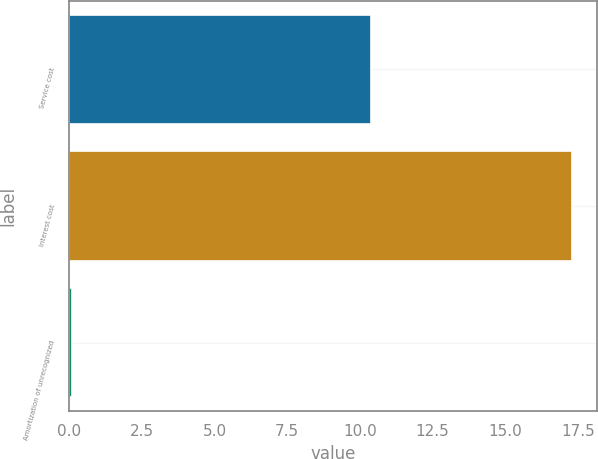Convert chart to OTSL. <chart><loc_0><loc_0><loc_500><loc_500><bar_chart><fcel>Service cost<fcel>Interest cost<fcel>Amortization of unrecognized<nl><fcel>10.4<fcel>17.3<fcel>0.1<nl></chart> 